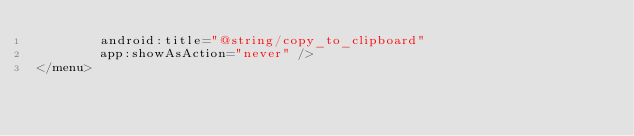Convert code to text. <code><loc_0><loc_0><loc_500><loc_500><_XML_>        android:title="@string/copy_to_clipboard"
        app:showAsAction="never" />
</menu></code> 